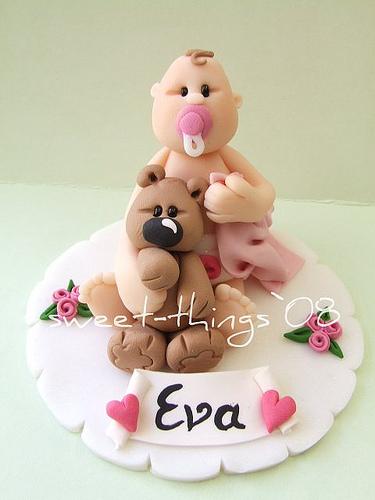Is Eva the little bear?
Keep it brief. No. Are there roses in this photo?
Concise answer only. Yes. What year is this from?
Quick response, please. 2008. 